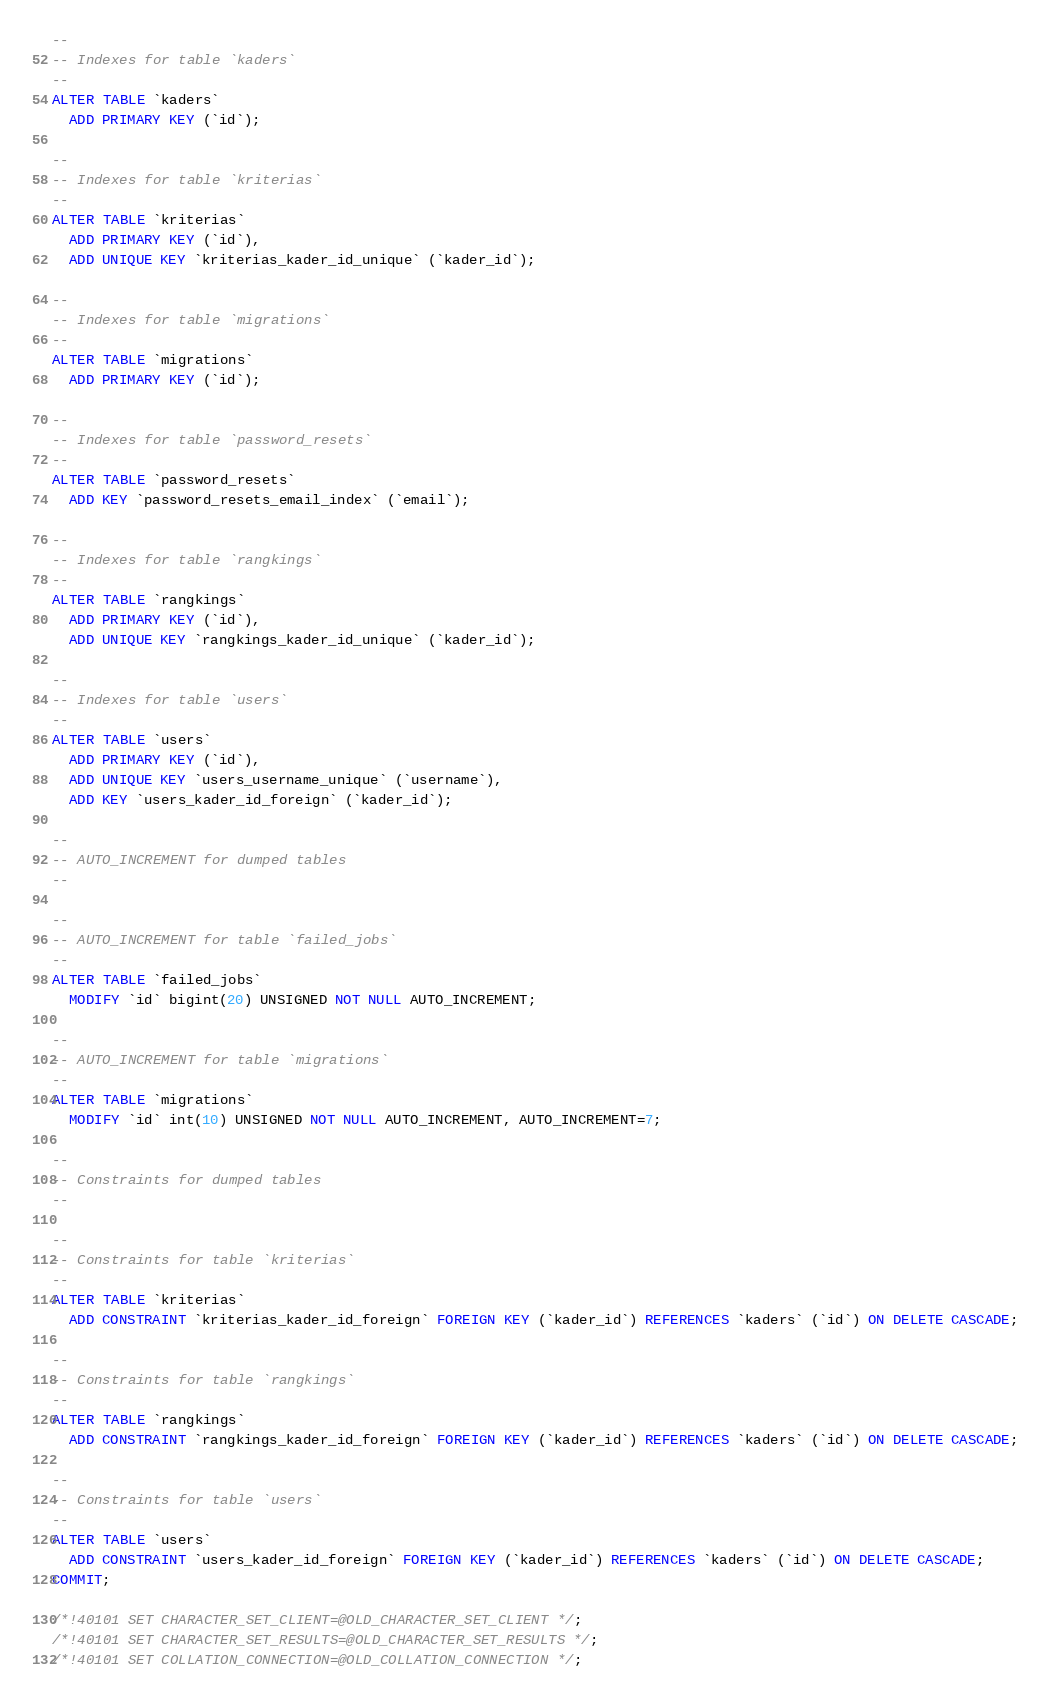Convert code to text. <code><loc_0><loc_0><loc_500><loc_500><_SQL_>
--
-- Indexes for table `kaders`
--
ALTER TABLE `kaders`
  ADD PRIMARY KEY (`id`);

--
-- Indexes for table `kriterias`
--
ALTER TABLE `kriterias`
  ADD PRIMARY KEY (`id`),
  ADD UNIQUE KEY `kriterias_kader_id_unique` (`kader_id`);

--
-- Indexes for table `migrations`
--
ALTER TABLE `migrations`
  ADD PRIMARY KEY (`id`);

--
-- Indexes for table `password_resets`
--
ALTER TABLE `password_resets`
  ADD KEY `password_resets_email_index` (`email`);

--
-- Indexes for table `rangkings`
--
ALTER TABLE `rangkings`
  ADD PRIMARY KEY (`id`),
  ADD UNIQUE KEY `rangkings_kader_id_unique` (`kader_id`);

--
-- Indexes for table `users`
--
ALTER TABLE `users`
  ADD PRIMARY KEY (`id`),
  ADD UNIQUE KEY `users_username_unique` (`username`),
  ADD KEY `users_kader_id_foreign` (`kader_id`);

--
-- AUTO_INCREMENT for dumped tables
--

--
-- AUTO_INCREMENT for table `failed_jobs`
--
ALTER TABLE `failed_jobs`
  MODIFY `id` bigint(20) UNSIGNED NOT NULL AUTO_INCREMENT;

--
-- AUTO_INCREMENT for table `migrations`
--
ALTER TABLE `migrations`
  MODIFY `id` int(10) UNSIGNED NOT NULL AUTO_INCREMENT, AUTO_INCREMENT=7;

--
-- Constraints for dumped tables
--

--
-- Constraints for table `kriterias`
--
ALTER TABLE `kriterias`
  ADD CONSTRAINT `kriterias_kader_id_foreign` FOREIGN KEY (`kader_id`) REFERENCES `kaders` (`id`) ON DELETE CASCADE;

--
-- Constraints for table `rangkings`
--
ALTER TABLE `rangkings`
  ADD CONSTRAINT `rangkings_kader_id_foreign` FOREIGN KEY (`kader_id`) REFERENCES `kaders` (`id`) ON DELETE CASCADE;

--
-- Constraints for table `users`
--
ALTER TABLE `users`
  ADD CONSTRAINT `users_kader_id_foreign` FOREIGN KEY (`kader_id`) REFERENCES `kaders` (`id`) ON DELETE CASCADE;
COMMIT;

/*!40101 SET CHARACTER_SET_CLIENT=@OLD_CHARACTER_SET_CLIENT */;
/*!40101 SET CHARACTER_SET_RESULTS=@OLD_CHARACTER_SET_RESULTS */;
/*!40101 SET COLLATION_CONNECTION=@OLD_COLLATION_CONNECTION */;
</code> 